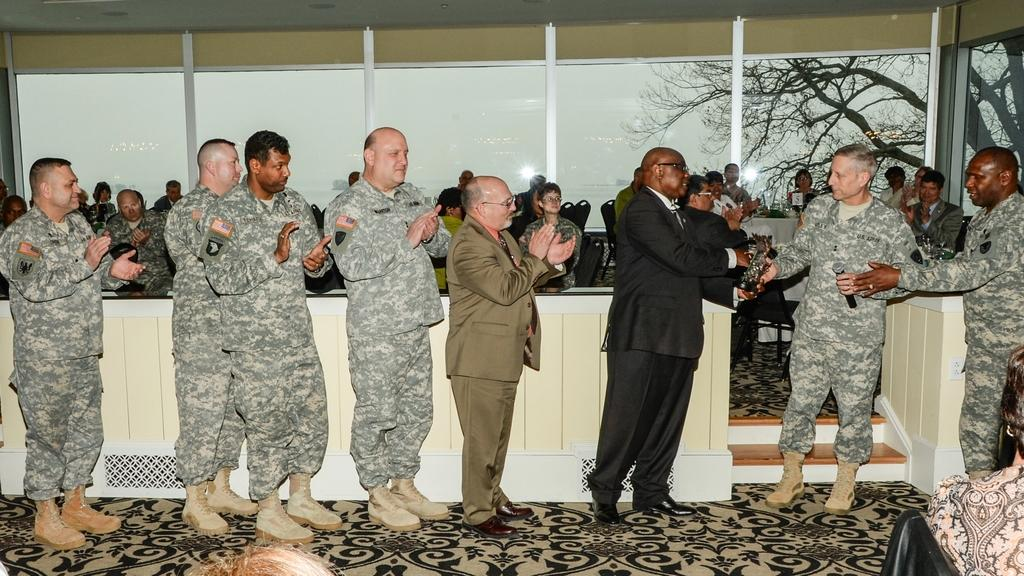Who or what can be seen in the image? There are people in the image. What is the surface that the people are standing or sitting on? There is a floor visible in the image. What type of furniture is present in the image? There are chairs in the image. What can be seen in the background of the image? There are glass windows in the background of the image, and trees and the sky are visible through them. What type of record is being played in the image? There is no record or music player present in the image. Who is wearing a crown in the image? There is no crown or person wearing a crown in the image. 